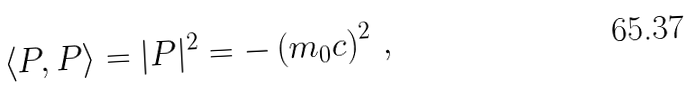Convert formula to latex. <formula><loc_0><loc_0><loc_500><loc_500>\left \langle P , P \right \rangle = | P | ^ { 2 } = - \left ( m _ { 0 } c \right ) ^ { 2 } \, ,</formula> 